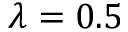<formula> <loc_0><loc_0><loc_500><loc_500>\lambda = 0 . 5</formula> 